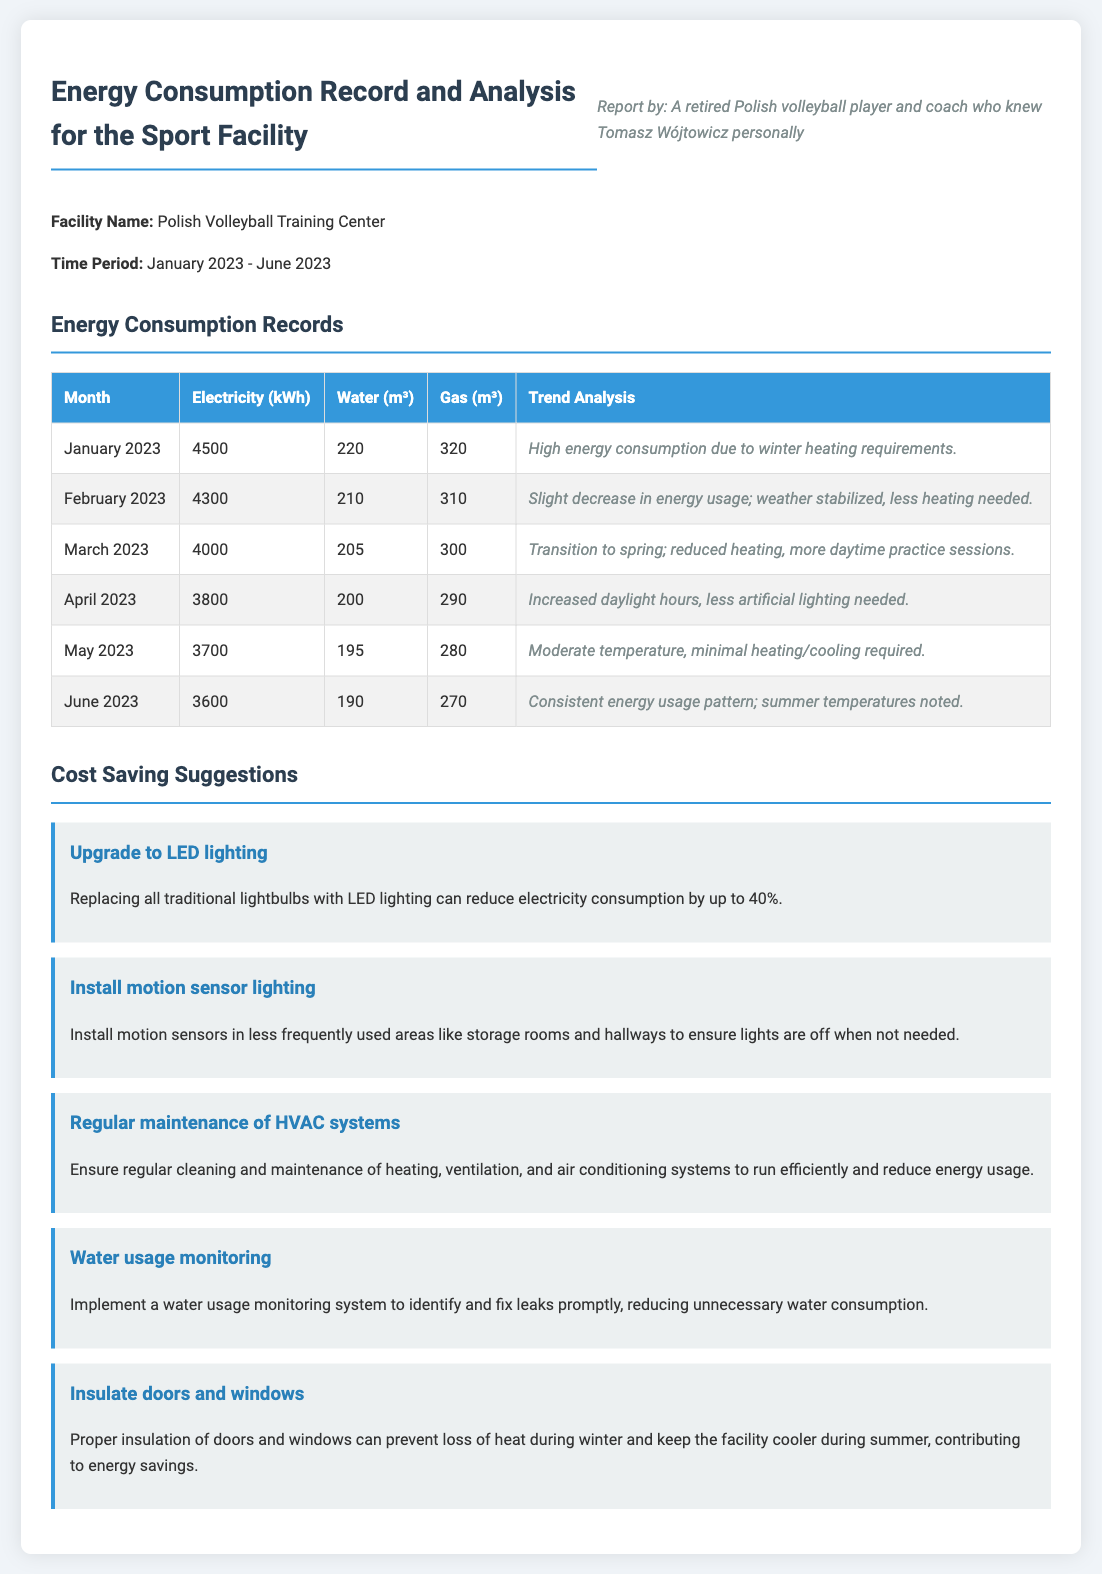What is the facility name? The facility name is mentioned in the document as "Polish Volleyball Training Center."
Answer: Polish Volleyball Training Center What was the electricity consumption in March 2023? The document lists the electricity consumption for March 2023 as 4000 kWh.
Answer: 4000 kWh Which month had the highest water usage? By comparing the water usage across the months, January 2023 shows the highest usage at 220 m³.
Answer: 220 m³ What trend analysis is noted for April 2023? The trend analysis for April 2023 states "Increased daylight hours, less artificial lighting needed."
Answer: Increased daylight hours, less artificial lighting needed How much did gas consumption decrease from January to June 2023? The gas consumption in January 2023 was 320 m³ and decreased to 270 m³ by June, reflecting a decrease of 50 m³.
Answer: 50 m³ Which suggestion aims to reduce electricity consumption? The document includes multiple suggestions, one of which is to "Upgrade to LED lighting" to reduce electricity consumption.
Answer: Upgrade to LED lighting What is one suggestion for water usage? The document suggests "Implement a water usage monitoring system" to address water consumption efficiently.
Answer: Implement a water usage monitoring system Which month showed a transition to spring according to the trend analysis? The trend analysis mentions March 2023 as the month transitioning to spring.
Answer: March 2023 What is the period covered in the energy consumption report? The document indicates the period covered is from January 2023 to June 2023.
Answer: January 2023 - June 2023 